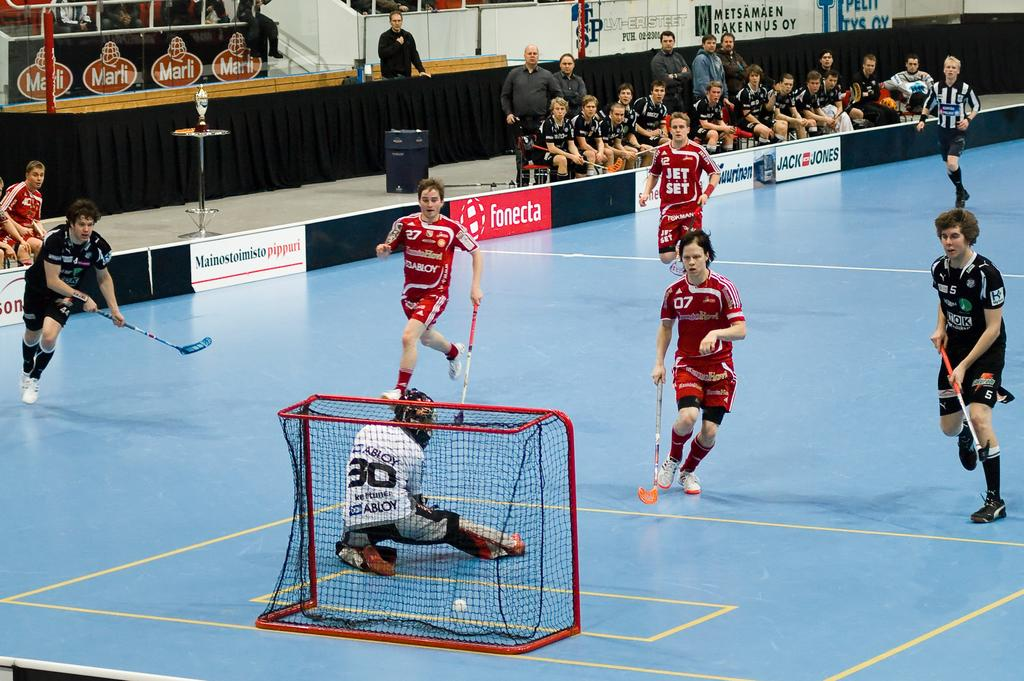<image>
Share a concise interpretation of the image provided. Abloy is one of the sponsors of the team in red. 